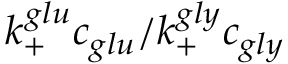Convert formula to latex. <formula><loc_0><loc_0><loc_500><loc_500>k _ { + } ^ { g l u } c _ { g l u } / k _ { + } ^ { g l y } c _ { g l y }</formula> 